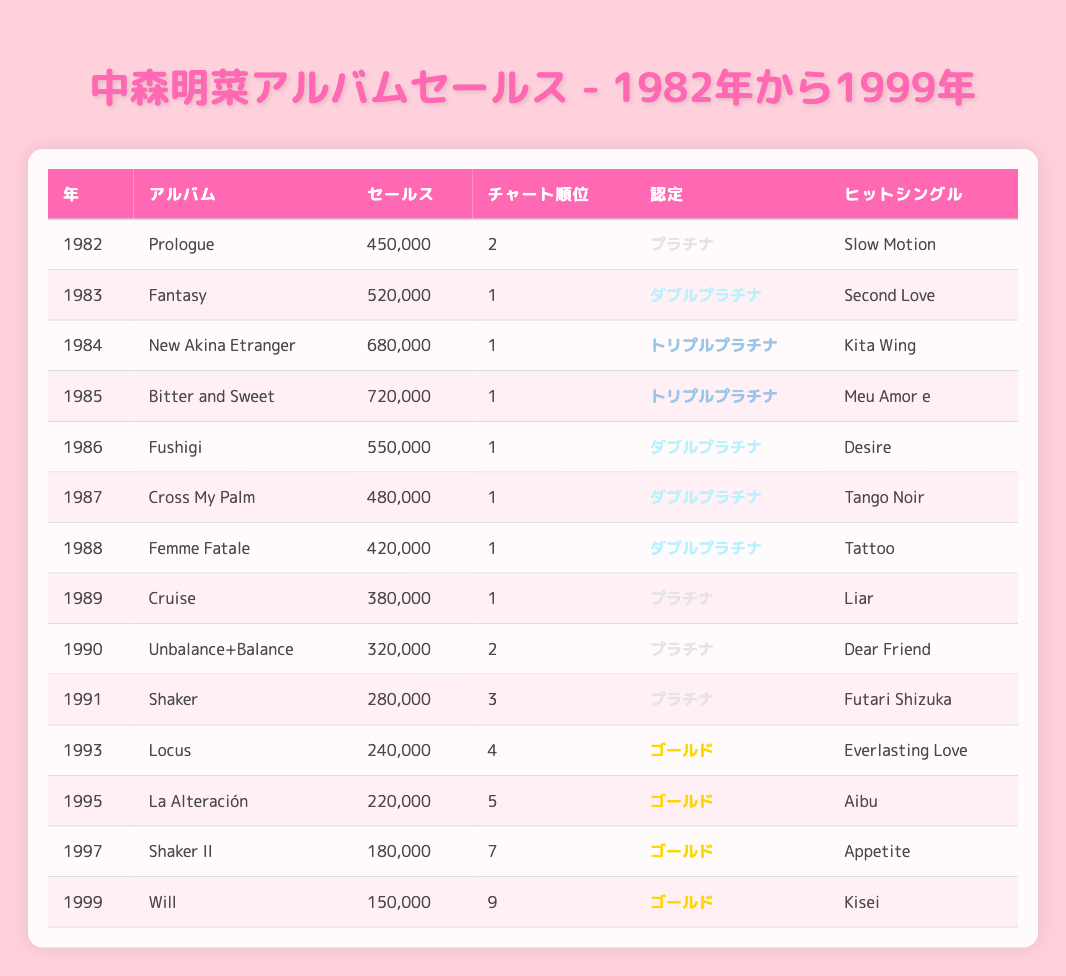What was the highest album sales for Akina Nakamori from 1982 to 1999? The highest album sales are found in the year 1985 with "Bitter and Sweet" having sales of 720,000.
Answer: 720,000 Which album had the lowest chart position? The album with the lowest chart position is "Will" from 1999, which reached a chart position of 9.
Answer: 9 How many albums achieved Triple Platinum certification? The albums achieving Triple Platinum certification are "New Akina Etranger" and "Bitter and Sweet," making a total of 2 albums.
Answer: 2 What is the average sales figure of albums certified as Gold? First, identify the albums with Gold certification: "Locus," "La Alteración," "Shaker II," and "Will," with sales figures of 240,000, 220,000, 180,000, and 150,000 respectively. Their total sales = 240,000 + 220,000 + 180,000 + 150,000 = 790,000. The average is 790,000 divided by 4, which equals 197,500.
Answer: 197,500 Was there any year when Akina Nakamori released two albums? No, there were no years listed where Akina released more than one album. Each year has a unique album associated with it.
Answer: No In which year did Akina Nakamori's album "Femme Fatale" achieve its peak position? "Femme Fatale" reached its peak chart position in 1988, where it held the position of 1.
Answer: 1 What percentage of albums released from 1982 to 1999 were certified as Double Platinum or higher? There are 8 albums total in the dataset. The following albums are certified as Double Platinum or higher: "Fantasy," "New Akina Etranger," "Bitter and Sweet," "Fushigi," "Cross My Palm," "Femme Fatale," and "Cruise." That makes 7 albums. Thus, the percentage is (7/8) * 100 = 87.5%.
Answer: 87.5% Which hit single corresponds to the album with the second highest sales? The album with the second highest sales is "New Akina Etranger" with sales of 680,000, and its hit single is "Kita Wing."
Answer: Kita Wing What is the trend in album sales from 1982 to 1999? Observing the sales figures, there was a peak in the mid to late 1980s, with sales decreasing notably in the 1990s. This decline suggests a trend of reduced popularity over time.
Answer: Decrease in sales over time 